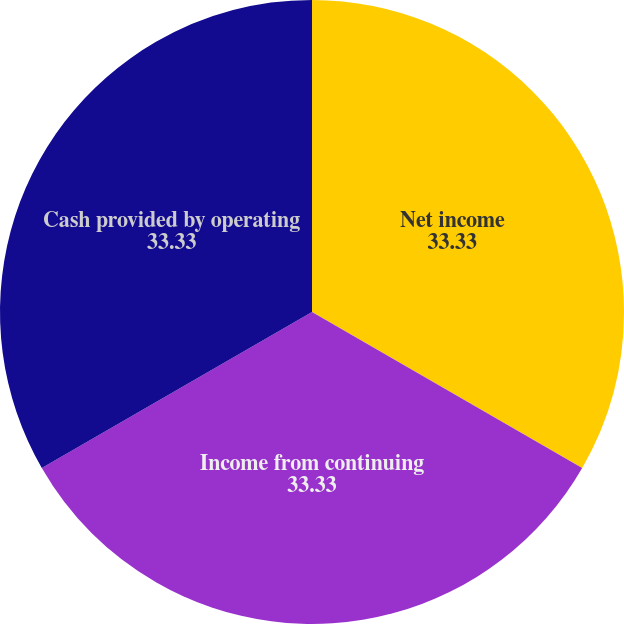Convert chart. <chart><loc_0><loc_0><loc_500><loc_500><pie_chart><fcel>Net income<fcel>Income from continuing<fcel>Cash provided by operating<nl><fcel>33.33%<fcel>33.33%<fcel>33.33%<nl></chart> 